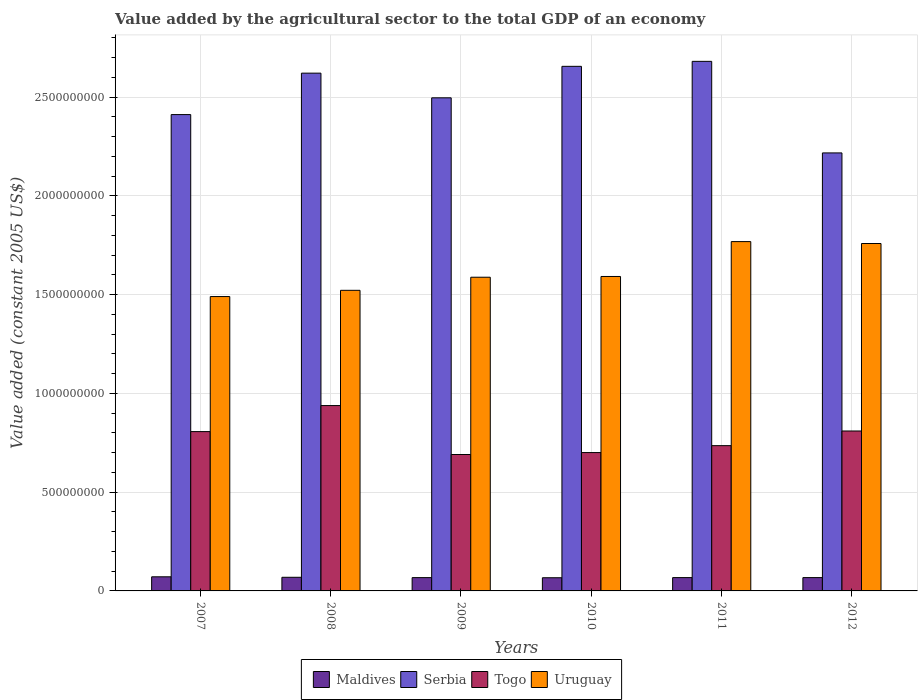How many groups of bars are there?
Keep it short and to the point. 6. Are the number of bars per tick equal to the number of legend labels?
Your response must be concise. Yes. Are the number of bars on each tick of the X-axis equal?
Keep it short and to the point. Yes. How many bars are there on the 5th tick from the right?
Offer a very short reply. 4. What is the label of the 6th group of bars from the left?
Your answer should be compact. 2012. What is the value added by the agricultural sector in Uruguay in 2010?
Your response must be concise. 1.59e+09. Across all years, what is the maximum value added by the agricultural sector in Togo?
Provide a succinct answer. 9.38e+08. Across all years, what is the minimum value added by the agricultural sector in Togo?
Your response must be concise. 6.91e+08. In which year was the value added by the agricultural sector in Togo maximum?
Ensure brevity in your answer.  2008. In which year was the value added by the agricultural sector in Uruguay minimum?
Give a very brief answer. 2007. What is the total value added by the agricultural sector in Serbia in the graph?
Ensure brevity in your answer.  1.51e+1. What is the difference between the value added by the agricultural sector in Maldives in 2011 and that in 2012?
Offer a very short reply. 2.60e+04. What is the difference between the value added by the agricultural sector in Serbia in 2007 and the value added by the agricultural sector in Togo in 2009?
Your response must be concise. 1.72e+09. What is the average value added by the agricultural sector in Maldives per year?
Your answer should be very brief. 6.82e+07. In the year 2007, what is the difference between the value added by the agricultural sector in Serbia and value added by the agricultural sector in Togo?
Ensure brevity in your answer.  1.60e+09. In how many years, is the value added by the agricultural sector in Serbia greater than 2400000000 US$?
Ensure brevity in your answer.  5. What is the ratio of the value added by the agricultural sector in Serbia in 2010 to that in 2011?
Your response must be concise. 0.99. Is the value added by the agricultural sector in Uruguay in 2007 less than that in 2012?
Your answer should be very brief. Yes. What is the difference between the highest and the second highest value added by the agricultural sector in Togo?
Provide a succinct answer. 1.29e+08. What is the difference between the highest and the lowest value added by the agricultural sector in Maldives?
Your answer should be very brief. 4.72e+06. In how many years, is the value added by the agricultural sector in Uruguay greater than the average value added by the agricultural sector in Uruguay taken over all years?
Your answer should be very brief. 2. Is it the case that in every year, the sum of the value added by the agricultural sector in Maldives and value added by the agricultural sector in Serbia is greater than the sum of value added by the agricultural sector in Uruguay and value added by the agricultural sector in Togo?
Keep it short and to the point. Yes. What does the 4th bar from the left in 2009 represents?
Ensure brevity in your answer.  Uruguay. What does the 1st bar from the right in 2012 represents?
Offer a terse response. Uruguay. Is it the case that in every year, the sum of the value added by the agricultural sector in Uruguay and value added by the agricultural sector in Serbia is greater than the value added by the agricultural sector in Togo?
Keep it short and to the point. Yes. What is the difference between two consecutive major ticks on the Y-axis?
Provide a short and direct response. 5.00e+08. Are the values on the major ticks of Y-axis written in scientific E-notation?
Provide a succinct answer. No. How are the legend labels stacked?
Provide a short and direct response. Horizontal. What is the title of the graph?
Keep it short and to the point. Value added by the agricultural sector to the total GDP of an economy. Does "Tuvalu" appear as one of the legend labels in the graph?
Ensure brevity in your answer.  No. What is the label or title of the X-axis?
Give a very brief answer. Years. What is the label or title of the Y-axis?
Your response must be concise. Value added (constant 2005 US$). What is the Value added (constant 2005 US$) of Maldives in 2007?
Keep it short and to the point. 7.14e+07. What is the Value added (constant 2005 US$) of Serbia in 2007?
Ensure brevity in your answer.  2.41e+09. What is the Value added (constant 2005 US$) in Togo in 2007?
Your response must be concise. 8.06e+08. What is the Value added (constant 2005 US$) in Uruguay in 2007?
Offer a very short reply. 1.49e+09. What is the Value added (constant 2005 US$) in Maldives in 2008?
Ensure brevity in your answer.  6.90e+07. What is the Value added (constant 2005 US$) of Serbia in 2008?
Provide a short and direct response. 2.62e+09. What is the Value added (constant 2005 US$) of Togo in 2008?
Give a very brief answer. 9.38e+08. What is the Value added (constant 2005 US$) of Uruguay in 2008?
Your response must be concise. 1.52e+09. What is the Value added (constant 2005 US$) of Maldives in 2009?
Give a very brief answer. 6.73e+07. What is the Value added (constant 2005 US$) in Serbia in 2009?
Keep it short and to the point. 2.50e+09. What is the Value added (constant 2005 US$) of Togo in 2009?
Make the answer very short. 6.91e+08. What is the Value added (constant 2005 US$) in Uruguay in 2009?
Provide a succinct answer. 1.59e+09. What is the Value added (constant 2005 US$) of Maldives in 2010?
Provide a succinct answer. 6.67e+07. What is the Value added (constant 2005 US$) in Serbia in 2010?
Make the answer very short. 2.66e+09. What is the Value added (constant 2005 US$) in Togo in 2010?
Give a very brief answer. 7.00e+08. What is the Value added (constant 2005 US$) in Uruguay in 2010?
Provide a succinct answer. 1.59e+09. What is the Value added (constant 2005 US$) of Maldives in 2011?
Offer a very short reply. 6.74e+07. What is the Value added (constant 2005 US$) in Serbia in 2011?
Offer a terse response. 2.68e+09. What is the Value added (constant 2005 US$) of Togo in 2011?
Give a very brief answer. 7.35e+08. What is the Value added (constant 2005 US$) in Uruguay in 2011?
Provide a short and direct response. 1.77e+09. What is the Value added (constant 2005 US$) in Maldives in 2012?
Offer a terse response. 6.74e+07. What is the Value added (constant 2005 US$) of Serbia in 2012?
Your answer should be very brief. 2.22e+09. What is the Value added (constant 2005 US$) of Togo in 2012?
Ensure brevity in your answer.  8.10e+08. What is the Value added (constant 2005 US$) of Uruguay in 2012?
Keep it short and to the point. 1.76e+09. Across all years, what is the maximum Value added (constant 2005 US$) of Maldives?
Offer a terse response. 7.14e+07. Across all years, what is the maximum Value added (constant 2005 US$) of Serbia?
Offer a terse response. 2.68e+09. Across all years, what is the maximum Value added (constant 2005 US$) of Togo?
Give a very brief answer. 9.38e+08. Across all years, what is the maximum Value added (constant 2005 US$) in Uruguay?
Provide a succinct answer. 1.77e+09. Across all years, what is the minimum Value added (constant 2005 US$) in Maldives?
Make the answer very short. 6.67e+07. Across all years, what is the minimum Value added (constant 2005 US$) of Serbia?
Provide a succinct answer. 2.22e+09. Across all years, what is the minimum Value added (constant 2005 US$) in Togo?
Offer a terse response. 6.91e+08. Across all years, what is the minimum Value added (constant 2005 US$) of Uruguay?
Give a very brief answer. 1.49e+09. What is the total Value added (constant 2005 US$) of Maldives in the graph?
Your response must be concise. 4.09e+08. What is the total Value added (constant 2005 US$) in Serbia in the graph?
Make the answer very short. 1.51e+1. What is the total Value added (constant 2005 US$) of Togo in the graph?
Provide a short and direct response. 4.68e+09. What is the total Value added (constant 2005 US$) of Uruguay in the graph?
Make the answer very short. 9.72e+09. What is the difference between the Value added (constant 2005 US$) in Maldives in 2007 and that in 2008?
Offer a very short reply. 2.43e+06. What is the difference between the Value added (constant 2005 US$) of Serbia in 2007 and that in 2008?
Your response must be concise. -2.10e+08. What is the difference between the Value added (constant 2005 US$) of Togo in 2007 and that in 2008?
Your answer should be very brief. -1.32e+08. What is the difference between the Value added (constant 2005 US$) of Uruguay in 2007 and that in 2008?
Your response must be concise. -3.15e+07. What is the difference between the Value added (constant 2005 US$) of Maldives in 2007 and that in 2009?
Provide a short and direct response. 4.13e+06. What is the difference between the Value added (constant 2005 US$) in Serbia in 2007 and that in 2009?
Your response must be concise. -8.49e+07. What is the difference between the Value added (constant 2005 US$) of Togo in 2007 and that in 2009?
Make the answer very short. 1.16e+08. What is the difference between the Value added (constant 2005 US$) of Uruguay in 2007 and that in 2009?
Give a very brief answer. -9.78e+07. What is the difference between the Value added (constant 2005 US$) in Maldives in 2007 and that in 2010?
Offer a very short reply. 4.72e+06. What is the difference between the Value added (constant 2005 US$) of Serbia in 2007 and that in 2010?
Make the answer very short. -2.44e+08. What is the difference between the Value added (constant 2005 US$) of Togo in 2007 and that in 2010?
Ensure brevity in your answer.  1.06e+08. What is the difference between the Value added (constant 2005 US$) in Uruguay in 2007 and that in 2010?
Your answer should be very brief. -1.02e+08. What is the difference between the Value added (constant 2005 US$) in Maldives in 2007 and that in 2011?
Provide a short and direct response. 4.01e+06. What is the difference between the Value added (constant 2005 US$) in Serbia in 2007 and that in 2011?
Ensure brevity in your answer.  -2.69e+08. What is the difference between the Value added (constant 2005 US$) of Togo in 2007 and that in 2011?
Offer a very short reply. 7.11e+07. What is the difference between the Value added (constant 2005 US$) of Uruguay in 2007 and that in 2011?
Make the answer very short. -2.78e+08. What is the difference between the Value added (constant 2005 US$) in Maldives in 2007 and that in 2012?
Your response must be concise. 4.04e+06. What is the difference between the Value added (constant 2005 US$) in Serbia in 2007 and that in 2012?
Offer a very short reply. 1.94e+08. What is the difference between the Value added (constant 2005 US$) in Togo in 2007 and that in 2012?
Provide a succinct answer. -3.08e+06. What is the difference between the Value added (constant 2005 US$) of Uruguay in 2007 and that in 2012?
Provide a succinct answer. -2.69e+08. What is the difference between the Value added (constant 2005 US$) in Maldives in 2008 and that in 2009?
Ensure brevity in your answer.  1.70e+06. What is the difference between the Value added (constant 2005 US$) of Serbia in 2008 and that in 2009?
Make the answer very short. 1.25e+08. What is the difference between the Value added (constant 2005 US$) of Togo in 2008 and that in 2009?
Your answer should be very brief. 2.48e+08. What is the difference between the Value added (constant 2005 US$) of Uruguay in 2008 and that in 2009?
Offer a terse response. -6.63e+07. What is the difference between the Value added (constant 2005 US$) of Maldives in 2008 and that in 2010?
Provide a short and direct response. 2.29e+06. What is the difference between the Value added (constant 2005 US$) of Serbia in 2008 and that in 2010?
Your response must be concise. -3.45e+07. What is the difference between the Value added (constant 2005 US$) of Togo in 2008 and that in 2010?
Your answer should be very brief. 2.38e+08. What is the difference between the Value added (constant 2005 US$) of Uruguay in 2008 and that in 2010?
Your answer should be very brief. -7.01e+07. What is the difference between the Value added (constant 2005 US$) of Maldives in 2008 and that in 2011?
Your answer should be very brief. 1.59e+06. What is the difference between the Value added (constant 2005 US$) in Serbia in 2008 and that in 2011?
Provide a succinct answer. -5.97e+07. What is the difference between the Value added (constant 2005 US$) of Togo in 2008 and that in 2011?
Keep it short and to the point. 2.03e+08. What is the difference between the Value added (constant 2005 US$) of Uruguay in 2008 and that in 2011?
Provide a short and direct response. -2.47e+08. What is the difference between the Value added (constant 2005 US$) in Maldives in 2008 and that in 2012?
Ensure brevity in your answer.  1.61e+06. What is the difference between the Value added (constant 2005 US$) of Serbia in 2008 and that in 2012?
Offer a very short reply. 4.04e+08. What is the difference between the Value added (constant 2005 US$) of Togo in 2008 and that in 2012?
Keep it short and to the point. 1.29e+08. What is the difference between the Value added (constant 2005 US$) in Uruguay in 2008 and that in 2012?
Provide a succinct answer. -2.37e+08. What is the difference between the Value added (constant 2005 US$) of Maldives in 2009 and that in 2010?
Your answer should be very brief. 5.91e+05. What is the difference between the Value added (constant 2005 US$) of Serbia in 2009 and that in 2010?
Your answer should be compact. -1.59e+08. What is the difference between the Value added (constant 2005 US$) of Togo in 2009 and that in 2010?
Offer a very short reply. -9.86e+06. What is the difference between the Value added (constant 2005 US$) of Uruguay in 2009 and that in 2010?
Provide a short and direct response. -3.84e+06. What is the difference between the Value added (constant 2005 US$) of Maldives in 2009 and that in 2011?
Keep it short and to the point. -1.14e+05. What is the difference between the Value added (constant 2005 US$) in Serbia in 2009 and that in 2011?
Ensure brevity in your answer.  -1.85e+08. What is the difference between the Value added (constant 2005 US$) of Togo in 2009 and that in 2011?
Provide a succinct answer. -4.48e+07. What is the difference between the Value added (constant 2005 US$) in Uruguay in 2009 and that in 2011?
Ensure brevity in your answer.  -1.80e+08. What is the difference between the Value added (constant 2005 US$) of Maldives in 2009 and that in 2012?
Ensure brevity in your answer.  -8.76e+04. What is the difference between the Value added (constant 2005 US$) in Serbia in 2009 and that in 2012?
Keep it short and to the point. 2.79e+08. What is the difference between the Value added (constant 2005 US$) in Togo in 2009 and that in 2012?
Provide a succinct answer. -1.19e+08. What is the difference between the Value added (constant 2005 US$) in Uruguay in 2009 and that in 2012?
Provide a succinct answer. -1.71e+08. What is the difference between the Value added (constant 2005 US$) in Maldives in 2010 and that in 2011?
Keep it short and to the point. -7.04e+05. What is the difference between the Value added (constant 2005 US$) in Serbia in 2010 and that in 2011?
Offer a terse response. -2.52e+07. What is the difference between the Value added (constant 2005 US$) in Togo in 2010 and that in 2011?
Keep it short and to the point. -3.50e+07. What is the difference between the Value added (constant 2005 US$) of Uruguay in 2010 and that in 2011?
Ensure brevity in your answer.  -1.77e+08. What is the difference between the Value added (constant 2005 US$) of Maldives in 2010 and that in 2012?
Provide a succinct answer. -6.78e+05. What is the difference between the Value added (constant 2005 US$) of Serbia in 2010 and that in 2012?
Your answer should be very brief. 4.38e+08. What is the difference between the Value added (constant 2005 US$) of Togo in 2010 and that in 2012?
Provide a short and direct response. -1.09e+08. What is the difference between the Value added (constant 2005 US$) of Uruguay in 2010 and that in 2012?
Provide a short and direct response. -1.67e+08. What is the difference between the Value added (constant 2005 US$) of Maldives in 2011 and that in 2012?
Ensure brevity in your answer.  2.60e+04. What is the difference between the Value added (constant 2005 US$) of Serbia in 2011 and that in 2012?
Your answer should be very brief. 4.64e+08. What is the difference between the Value added (constant 2005 US$) of Togo in 2011 and that in 2012?
Provide a succinct answer. -7.42e+07. What is the difference between the Value added (constant 2005 US$) in Uruguay in 2011 and that in 2012?
Give a very brief answer. 9.68e+06. What is the difference between the Value added (constant 2005 US$) in Maldives in 2007 and the Value added (constant 2005 US$) in Serbia in 2008?
Give a very brief answer. -2.55e+09. What is the difference between the Value added (constant 2005 US$) of Maldives in 2007 and the Value added (constant 2005 US$) of Togo in 2008?
Provide a succinct answer. -8.67e+08. What is the difference between the Value added (constant 2005 US$) in Maldives in 2007 and the Value added (constant 2005 US$) in Uruguay in 2008?
Provide a succinct answer. -1.45e+09. What is the difference between the Value added (constant 2005 US$) of Serbia in 2007 and the Value added (constant 2005 US$) of Togo in 2008?
Provide a short and direct response. 1.47e+09. What is the difference between the Value added (constant 2005 US$) of Serbia in 2007 and the Value added (constant 2005 US$) of Uruguay in 2008?
Give a very brief answer. 8.90e+08. What is the difference between the Value added (constant 2005 US$) in Togo in 2007 and the Value added (constant 2005 US$) in Uruguay in 2008?
Your answer should be compact. -7.15e+08. What is the difference between the Value added (constant 2005 US$) in Maldives in 2007 and the Value added (constant 2005 US$) in Serbia in 2009?
Provide a succinct answer. -2.42e+09. What is the difference between the Value added (constant 2005 US$) of Maldives in 2007 and the Value added (constant 2005 US$) of Togo in 2009?
Your response must be concise. -6.19e+08. What is the difference between the Value added (constant 2005 US$) of Maldives in 2007 and the Value added (constant 2005 US$) of Uruguay in 2009?
Offer a terse response. -1.52e+09. What is the difference between the Value added (constant 2005 US$) in Serbia in 2007 and the Value added (constant 2005 US$) in Togo in 2009?
Give a very brief answer. 1.72e+09. What is the difference between the Value added (constant 2005 US$) in Serbia in 2007 and the Value added (constant 2005 US$) in Uruguay in 2009?
Your answer should be very brief. 8.23e+08. What is the difference between the Value added (constant 2005 US$) of Togo in 2007 and the Value added (constant 2005 US$) of Uruguay in 2009?
Provide a short and direct response. -7.81e+08. What is the difference between the Value added (constant 2005 US$) of Maldives in 2007 and the Value added (constant 2005 US$) of Serbia in 2010?
Make the answer very short. -2.58e+09. What is the difference between the Value added (constant 2005 US$) of Maldives in 2007 and the Value added (constant 2005 US$) of Togo in 2010?
Offer a terse response. -6.29e+08. What is the difference between the Value added (constant 2005 US$) in Maldives in 2007 and the Value added (constant 2005 US$) in Uruguay in 2010?
Make the answer very short. -1.52e+09. What is the difference between the Value added (constant 2005 US$) in Serbia in 2007 and the Value added (constant 2005 US$) in Togo in 2010?
Your answer should be very brief. 1.71e+09. What is the difference between the Value added (constant 2005 US$) in Serbia in 2007 and the Value added (constant 2005 US$) in Uruguay in 2010?
Your answer should be compact. 8.19e+08. What is the difference between the Value added (constant 2005 US$) of Togo in 2007 and the Value added (constant 2005 US$) of Uruguay in 2010?
Offer a terse response. -7.85e+08. What is the difference between the Value added (constant 2005 US$) of Maldives in 2007 and the Value added (constant 2005 US$) of Serbia in 2011?
Give a very brief answer. -2.61e+09. What is the difference between the Value added (constant 2005 US$) of Maldives in 2007 and the Value added (constant 2005 US$) of Togo in 2011?
Give a very brief answer. -6.64e+08. What is the difference between the Value added (constant 2005 US$) of Maldives in 2007 and the Value added (constant 2005 US$) of Uruguay in 2011?
Offer a very short reply. -1.70e+09. What is the difference between the Value added (constant 2005 US$) of Serbia in 2007 and the Value added (constant 2005 US$) of Togo in 2011?
Ensure brevity in your answer.  1.68e+09. What is the difference between the Value added (constant 2005 US$) of Serbia in 2007 and the Value added (constant 2005 US$) of Uruguay in 2011?
Keep it short and to the point. 6.43e+08. What is the difference between the Value added (constant 2005 US$) in Togo in 2007 and the Value added (constant 2005 US$) in Uruguay in 2011?
Ensure brevity in your answer.  -9.62e+08. What is the difference between the Value added (constant 2005 US$) in Maldives in 2007 and the Value added (constant 2005 US$) in Serbia in 2012?
Make the answer very short. -2.15e+09. What is the difference between the Value added (constant 2005 US$) of Maldives in 2007 and the Value added (constant 2005 US$) of Togo in 2012?
Your response must be concise. -7.38e+08. What is the difference between the Value added (constant 2005 US$) in Maldives in 2007 and the Value added (constant 2005 US$) in Uruguay in 2012?
Ensure brevity in your answer.  -1.69e+09. What is the difference between the Value added (constant 2005 US$) in Serbia in 2007 and the Value added (constant 2005 US$) in Togo in 2012?
Give a very brief answer. 1.60e+09. What is the difference between the Value added (constant 2005 US$) in Serbia in 2007 and the Value added (constant 2005 US$) in Uruguay in 2012?
Offer a very short reply. 6.53e+08. What is the difference between the Value added (constant 2005 US$) of Togo in 2007 and the Value added (constant 2005 US$) of Uruguay in 2012?
Keep it short and to the point. -9.52e+08. What is the difference between the Value added (constant 2005 US$) in Maldives in 2008 and the Value added (constant 2005 US$) in Serbia in 2009?
Provide a short and direct response. -2.43e+09. What is the difference between the Value added (constant 2005 US$) of Maldives in 2008 and the Value added (constant 2005 US$) of Togo in 2009?
Provide a succinct answer. -6.22e+08. What is the difference between the Value added (constant 2005 US$) of Maldives in 2008 and the Value added (constant 2005 US$) of Uruguay in 2009?
Your response must be concise. -1.52e+09. What is the difference between the Value added (constant 2005 US$) in Serbia in 2008 and the Value added (constant 2005 US$) in Togo in 2009?
Give a very brief answer. 1.93e+09. What is the difference between the Value added (constant 2005 US$) of Serbia in 2008 and the Value added (constant 2005 US$) of Uruguay in 2009?
Ensure brevity in your answer.  1.03e+09. What is the difference between the Value added (constant 2005 US$) in Togo in 2008 and the Value added (constant 2005 US$) in Uruguay in 2009?
Offer a terse response. -6.50e+08. What is the difference between the Value added (constant 2005 US$) of Maldives in 2008 and the Value added (constant 2005 US$) of Serbia in 2010?
Your response must be concise. -2.59e+09. What is the difference between the Value added (constant 2005 US$) of Maldives in 2008 and the Value added (constant 2005 US$) of Togo in 2010?
Your response must be concise. -6.31e+08. What is the difference between the Value added (constant 2005 US$) in Maldives in 2008 and the Value added (constant 2005 US$) in Uruguay in 2010?
Your response must be concise. -1.52e+09. What is the difference between the Value added (constant 2005 US$) of Serbia in 2008 and the Value added (constant 2005 US$) of Togo in 2010?
Offer a terse response. 1.92e+09. What is the difference between the Value added (constant 2005 US$) in Serbia in 2008 and the Value added (constant 2005 US$) in Uruguay in 2010?
Keep it short and to the point. 1.03e+09. What is the difference between the Value added (constant 2005 US$) in Togo in 2008 and the Value added (constant 2005 US$) in Uruguay in 2010?
Offer a terse response. -6.54e+08. What is the difference between the Value added (constant 2005 US$) of Maldives in 2008 and the Value added (constant 2005 US$) of Serbia in 2011?
Offer a terse response. -2.61e+09. What is the difference between the Value added (constant 2005 US$) of Maldives in 2008 and the Value added (constant 2005 US$) of Togo in 2011?
Provide a short and direct response. -6.66e+08. What is the difference between the Value added (constant 2005 US$) in Maldives in 2008 and the Value added (constant 2005 US$) in Uruguay in 2011?
Provide a short and direct response. -1.70e+09. What is the difference between the Value added (constant 2005 US$) of Serbia in 2008 and the Value added (constant 2005 US$) of Togo in 2011?
Offer a terse response. 1.89e+09. What is the difference between the Value added (constant 2005 US$) of Serbia in 2008 and the Value added (constant 2005 US$) of Uruguay in 2011?
Provide a succinct answer. 8.53e+08. What is the difference between the Value added (constant 2005 US$) of Togo in 2008 and the Value added (constant 2005 US$) of Uruguay in 2011?
Your answer should be compact. -8.30e+08. What is the difference between the Value added (constant 2005 US$) in Maldives in 2008 and the Value added (constant 2005 US$) in Serbia in 2012?
Ensure brevity in your answer.  -2.15e+09. What is the difference between the Value added (constant 2005 US$) in Maldives in 2008 and the Value added (constant 2005 US$) in Togo in 2012?
Give a very brief answer. -7.41e+08. What is the difference between the Value added (constant 2005 US$) in Maldives in 2008 and the Value added (constant 2005 US$) in Uruguay in 2012?
Ensure brevity in your answer.  -1.69e+09. What is the difference between the Value added (constant 2005 US$) in Serbia in 2008 and the Value added (constant 2005 US$) in Togo in 2012?
Offer a very short reply. 1.81e+09. What is the difference between the Value added (constant 2005 US$) in Serbia in 2008 and the Value added (constant 2005 US$) in Uruguay in 2012?
Your answer should be compact. 8.62e+08. What is the difference between the Value added (constant 2005 US$) in Togo in 2008 and the Value added (constant 2005 US$) in Uruguay in 2012?
Keep it short and to the point. -8.20e+08. What is the difference between the Value added (constant 2005 US$) of Maldives in 2009 and the Value added (constant 2005 US$) of Serbia in 2010?
Provide a succinct answer. -2.59e+09. What is the difference between the Value added (constant 2005 US$) of Maldives in 2009 and the Value added (constant 2005 US$) of Togo in 2010?
Offer a terse response. -6.33e+08. What is the difference between the Value added (constant 2005 US$) of Maldives in 2009 and the Value added (constant 2005 US$) of Uruguay in 2010?
Provide a short and direct response. -1.52e+09. What is the difference between the Value added (constant 2005 US$) of Serbia in 2009 and the Value added (constant 2005 US$) of Togo in 2010?
Provide a succinct answer. 1.80e+09. What is the difference between the Value added (constant 2005 US$) in Serbia in 2009 and the Value added (constant 2005 US$) in Uruguay in 2010?
Provide a succinct answer. 9.04e+08. What is the difference between the Value added (constant 2005 US$) in Togo in 2009 and the Value added (constant 2005 US$) in Uruguay in 2010?
Your answer should be very brief. -9.01e+08. What is the difference between the Value added (constant 2005 US$) in Maldives in 2009 and the Value added (constant 2005 US$) in Serbia in 2011?
Keep it short and to the point. -2.61e+09. What is the difference between the Value added (constant 2005 US$) of Maldives in 2009 and the Value added (constant 2005 US$) of Togo in 2011?
Provide a succinct answer. -6.68e+08. What is the difference between the Value added (constant 2005 US$) in Maldives in 2009 and the Value added (constant 2005 US$) in Uruguay in 2011?
Your response must be concise. -1.70e+09. What is the difference between the Value added (constant 2005 US$) of Serbia in 2009 and the Value added (constant 2005 US$) of Togo in 2011?
Make the answer very short. 1.76e+09. What is the difference between the Value added (constant 2005 US$) in Serbia in 2009 and the Value added (constant 2005 US$) in Uruguay in 2011?
Your answer should be very brief. 7.28e+08. What is the difference between the Value added (constant 2005 US$) in Togo in 2009 and the Value added (constant 2005 US$) in Uruguay in 2011?
Provide a succinct answer. -1.08e+09. What is the difference between the Value added (constant 2005 US$) in Maldives in 2009 and the Value added (constant 2005 US$) in Serbia in 2012?
Give a very brief answer. -2.15e+09. What is the difference between the Value added (constant 2005 US$) in Maldives in 2009 and the Value added (constant 2005 US$) in Togo in 2012?
Ensure brevity in your answer.  -7.42e+08. What is the difference between the Value added (constant 2005 US$) of Maldives in 2009 and the Value added (constant 2005 US$) of Uruguay in 2012?
Provide a succinct answer. -1.69e+09. What is the difference between the Value added (constant 2005 US$) in Serbia in 2009 and the Value added (constant 2005 US$) in Togo in 2012?
Provide a short and direct response. 1.69e+09. What is the difference between the Value added (constant 2005 US$) in Serbia in 2009 and the Value added (constant 2005 US$) in Uruguay in 2012?
Give a very brief answer. 7.38e+08. What is the difference between the Value added (constant 2005 US$) in Togo in 2009 and the Value added (constant 2005 US$) in Uruguay in 2012?
Give a very brief answer. -1.07e+09. What is the difference between the Value added (constant 2005 US$) of Maldives in 2010 and the Value added (constant 2005 US$) of Serbia in 2011?
Ensure brevity in your answer.  -2.61e+09. What is the difference between the Value added (constant 2005 US$) of Maldives in 2010 and the Value added (constant 2005 US$) of Togo in 2011?
Provide a succinct answer. -6.69e+08. What is the difference between the Value added (constant 2005 US$) of Maldives in 2010 and the Value added (constant 2005 US$) of Uruguay in 2011?
Provide a short and direct response. -1.70e+09. What is the difference between the Value added (constant 2005 US$) in Serbia in 2010 and the Value added (constant 2005 US$) in Togo in 2011?
Provide a short and direct response. 1.92e+09. What is the difference between the Value added (constant 2005 US$) of Serbia in 2010 and the Value added (constant 2005 US$) of Uruguay in 2011?
Offer a terse response. 8.87e+08. What is the difference between the Value added (constant 2005 US$) in Togo in 2010 and the Value added (constant 2005 US$) in Uruguay in 2011?
Give a very brief answer. -1.07e+09. What is the difference between the Value added (constant 2005 US$) in Maldives in 2010 and the Value added (constant 2005 US$) in Serbia in 2012?
Ensure brevity in your answer.  -2.15e+09. What is the difference between the Value added (constant 2005 US$) in Maldives in 2010 and the Value added (constant 2005 US$) in Togo in 2012?
Keep it short and to the point. -7.43e+08. What is the difference between the Value added (constant 2005 US$) of Maldives in 2010 and the Value added (constant 2005 US$) of Uruguay in 2012?
Your response must be concise. -1.69e+09. What is the difference between the Value added (constant 2005 US$) in Serbia in 2010 and the Value added (constant 2005 US$) in Togo in 2012?
Make the answer very short. 1.85e+09. What is the difference between the Value added (constant 2005 US$) in Serbia in 2010 and the Value added (constant 2005 US$) in Uruguay in 2012?
Ensure brevity in your answer.  8.97e+08. What is the difference between the Value added (constant 2005 US$) in Togo in 2010 and the Value added (constant 2005 US$) in Uruguay in 2012?
Offer a very short reply. -1.06e+09. What is the difference between the Value added (constant 2005 US$) of Maldives in 2011 and the Value added (constant 2005 US$) of Serbia in 2012?
Your answer should be very brief. -2.15e+09. What is the difference between the Value added (constant 2005 US$) of Maldives in 2011 and the Value added (constant 2005 US$) of Togo in 2012?
Provide a short and direct response. -7.42e+08. What is the difference between the Value added (constant 2005 US$) in Maldives in 2011 and the Value added (constant 2005 US$) in Uruguay in 2012?
Make the answer very short. -1.69e+09. What is the difference between the Value added (constant 2005 US$) of Serbia in 2011 and the Value added (constant 2005 US$) of Togo in 2012?
Offer a terse response. 1.87e+09. What is the difference between the Value added (constant 2005 US$) of Serbia in 2011 and the Value added (constant 2005 US$) of Uruguay in 2012?
Your response must be concise. 9.22e+08. What is the difference between the Value added (constant 2005 US$) in Togo in 2011 and the Value added (constant 2005 US$) in Uruguay in 2012?
Ensure brevity in your answer.  -1.02e+09. What is the average Value added (constant 2005 US$) in Maldives per year?
Provide a short and direct response. 6.82e+07. What is the average Value added (constant 2005 US$) in Serbia per year?
Your answer should be compact. 2.51e+09. What is the average Value added (constant 2005 US$) of Togo per year?
Your answer should be compact. 7.80e+08. What is the average Value added (constant 2005 US$) of Uruguay per year?
Offer a terse response. 1.62e+09. In the year 2007, what is the difference between the Value added (constant 2005 US$) in Maldives and Value added (constant 2005 US$) in Serbia?
Provide a succinct answer. -2.34e+09. In the year 2007, what is the difference between the Value added (constant 2005 US$) in Maldives and Value added (constant 2005 US$) in Togo?
Your answer should be compact. -7.35e+08. In the year 2007, what is the difference between the Value added (constant 2005 US$) in Maldives and Value added (constant 2005 US$) in Uruguay?
Make the answer very short. -1.42e+09. In the year 2007, what is the difference between the Value added (constant 2005 US$) in Serbia and Value added (constant 2005 US$) in Togo?
Offer a terse response. 1.60e+09. In the year 2007, what is the difference between the Value added (constant 2005 US$) of Serbia and Value added (constant 2005 US$) of Uruguay?
Your answer should be compact. 9.21e+08. In the year 2007, what is the difference between the Value added (constant 2005 US$) of Togo and Value added (constant 2005 US$) of Uruguay?
Keep it short and to the point. -6.84e+08. In the year 2008, what is the difference between the Value added (constant 2005 US$) of Maldives and Value added (constant 2005 US$) of Serbia?
Ensure brevity in your answer.  -2.55e+09. In the year 2008, what is the difference between the Value added (constant 2005 US$) of Maldives and Value added (constant 2005 US$) of Togo?
Make the answer very short. -8.69e+08. In the year 2008, what is the difference between the Value added (constant 2005 US$) in Maldives and Value added (constant 2005 US$) in Uruguay?
Offer a very short reply. -1.45e+09. In the year 2008, what is the difference between the Value added (constant 2005 US$) of Serbia and Value added (constant 2005 US$) of Togo?
Ensure brevity in your answer.  1.68e+09. In the year 2008, what is the difference between the Value added (constant 2005 US$) in Serbia and Value added (constant 2005 US$) in Uruguay?
Give a very brief answer. 1.10e+09. In the year 2008, what is the difference between the Value added (constant 2005 US$) of Togo and Value added (constant 2005 US$) of Uruguay?
Offer a very short reply. -5.83e+08. In the year 2009, what is the difference between the Value added (constant 2005 US$) in Maldives and Value added (constant 2005 US$) in Serbia?
Provide a short and direct response. -2.43e+09. In the year 2009, what is the difference between the Value added (constant 2005 US$) of Maldives and Value added (constant 2005 US$) of Togo?
Offer a very short reply. -6.23e+08. In the year 2009, what is the difference between the Value added (constant 2005 US$) in Maldives and Value added (constant 2005 US$) in Uruguay?
Your answer should be compact. -1.52e+09. In the year 2009, what is the difference between the Value added (constant 2005 US$) in Serbia and Value added (constant 2005 US$) in Togo?
Your answer should be compact. 1.81e+09. In the year 2009, what is the difference between the Value added (constant 2005 US$) of Serbia and Value added (constant 2005 US$) of Uruguay?
Provide a short and direct response. 9.08e+08. In the year 2009, what is the difference between the Value added (constant 2005 US$) of Togo and Value added (constant 2005 US$) of Uruguay?
Provide a succinct answer. -8.97e+08. In the year 2010, what is the difference between the Value added (constant 2005 US$) in Maldives and Value added (constant 2005 US$) in Serbia?
Offer a terse response. -2.59e+09. In the year 2010, what is the difference between the Value added (constant 2005 US$) in Maldives and Value added (constant 2005 US$) in Togo?
Give a very brief answer. -6.34e+08. In the year 2010, what is the difference between the Value added (constant 2005 US$) in Maldives and Value added (constant 2005 US$) in Uruguay?
Provide a succinct answer. -1.53e+09. In the year 2010, what is the difference between the Value added (constant 2005 US$) in Serbia and Value added (constant 2005 US$) in Togo?
Provide a succinct answer. 1.96e+09. In the year 2010, what is the difference between the Value added (constant 2005 US$) of Serbia and Value added (constant 2005 US$) of Uruguay?
Your response must be concise. 1.06e+09. In the year 2010, what is the difference between the Value added (constant 2005 US$) of Togo and Value added (constant 2005 US$) of Uruguay?
Your answer should be very brief. -8.91e+08. In the year 2011, what is the difference between the Value added (constant 2005 US$) in Maldives and Value added (constant 2005 US$) in Serbia?
Make the answer very short. -2.61e+09. In the year 2011, what is the difference between the Value added (constant 2005 US$) of Maldives and Value added (constant 2005 US$) of Togo?
Keep it short and to the point. -6.68e+08. In the year 2011, what is the difference between the Value added (constant 2005 US$) in Maldives and Value added (constant 2005 US$) in Uruguay?
Your answer should be very brief. -1.70e+09. In the year 2011, what is the difference between the Value added (constant 2005 US$) in Serbia and Value added (constant 2005 US$) in Togo?
Your answer should be compact. 1.95e+09. In the year 2011, what is the difference between the Value added (constant 2005 US$) of Serbia and Value added (constant 2005 US$) of Uruguay?
Offer a terse response. 9.12e+08. In the year 2011, what is the difference between the Value added (constant 2005 US$) in Togo and Value added (constant 2005 US$) in Uruguay?
Provide a short and direct response. -1.03e+09. In the year 2012, what is the difference between the Value added (constant 2005 US$) of Maldives and Value added (constant 2005 US$) of Serbia?
Ensure brevity in your answer.  -2.15e+09. In the year 2012, what is the difference between the Value added (constant 2005 US$) in Maldives and Value added (constant 2005 US$) in Togo?
Provide a succinct answer. -7.42e+08. In the year 2012, what is the difference between the Value added (constant 2005 US$) in Maldives and Value added (constant 2005 US$) in Uruguay?
Offer a very short reply. -1.69e+09. In the year 2012, what is the difference between the Value added (constant 2005 US$) in Serbia and Value added (constant 2005 US$) in Togo?
Keep it short and to the point. 1.41e+09. In the year 2012, what is the difference between the Value added (constant 2005 US$) in Serbia and Value added (constant 2005 US$) in Uruguay?
Keep it short and to the point. 4.59e+08. In the year 2012, what is the difference between the Value added (constant 2005 US$) in Togo and Value added (constant 2005 US$) in Uruguay?
Ensure brevity in your answer.  -9.49e+08. What is the ratio of the Value added (constant 2005 US$) of Maldives in 2007 to that in 2008?
Offer a very short reply. 1.04. What is the ratio of the Value added (constant 2005 US$) in Togo in 2007 to that in 2008?
Provide a short and direct response. 0.86. What is the ratio of the Value added (constant 2005 US$) of Uruguay in 2007 to that in 2008?
Ensure brevity in your answer.  0.98. What is the ratio of the Value added (constant 2005 US$) in Maldives in 2007 to that in 2009?
Your response must be concise. 1.06. What is the ratio of the Value added (constant 2005 US$) of Togo in 2007 to that in 2009?
Ensure brevity in your answer.  1.17. What is the ratio of the Value added (constant 2005 US$) in Uruguay in 2007 to that in 2009?
Ensure brevity in your answer.  0.94. What is the ratio of the Value added (constant 2005 US$) in Maldives in 2007 to that in 2010?
Your answer should be compact. 1.07. What is the ratio of the Value added (constant 2005 US$) in Serbia in 2007 to that in 2010?
Make the answer very short. 0.91. What is the ratio of the Value added (constant 2005 US$) of Togo in 2007 to that in 2010?
Ensure brevity in your answer.  1.15. What is the ratio of the Value added (constant 2005 US$) in Uruguay in 2007 to that in 2010?
Keep it short and to the point. 0.94. What is the ratio of the Value added (constant 2005 US$) in Maldives in 2007 to that in 2011?
Offer a terse response. 1.06. What is the ratio of the Value added (constant 2005 US$) in Serbia in 2007 to that in 2011?
Your answer should be compact. 0.9. What is the ratio of the Value added (constant 2005 US$) in Togo in 2007 to that in 2011?
Make the answer very short. 1.1. What is the ratio of the Value added (constant 2005 US$) in Uruguay in 2007 to that in 2011?
Offer a terse response. 0.84. What is the ratio of the Value added (constant 2005 US$) in Maldives in 2007 to that in 2012?
Provide a succinct answer. 1.06. What is the ratio of the Value added (constant 2005 US$) in Serbia in 2007 to that in 2012?
Your answer should be compact. 1.09. What is the ratio of the Value added (constant 2005 US$) in Uruguay in 2007 to that in 2012?
Provide a succinct answer. 0.85. What is the ratio of the Value added (constant 2005 US$) in Maldives in 2008 to that in 2009?
Your response must be concise. 1.03. What is the ratio of the Value added (constant 2005 US$) in Togo in 2008 to that in 2009?
Offer a terse response. 1.36. What is the ratio of the Value added (constant 2005 US$) of Maldives in 2008 to that in 2010?
Offer a very short reply. 1.03. What is the ratio of the Value added (constant 2005 US$) in Togo in 2008 to that in 2010?
Provide a short and direct response. 1.34. What is the ratio of the Value added (constant 2005 US$) of Uruguay in 2008 to that in 2010?
Offer a terse response. 0.96. What is the ratio of the Value added (constant 2005 US$) in Maldives in 2008 to that in 2011?
Your response must be concise. 1.02. What is the ratio of the Value added (constant 2005 US$) of Serbia in 2008 to that in 2011?
Keep it short and to the point. 0.98. What is the ratio of the Value added (constant 2005 US$) in Togo in 2008 to that in 2011?
Your answer should be very brief. 1.28. What is the ratio of the Value added (constant 2005 US$) of Uruguay in 2008 to that in 2011?
Ensure brevity in your answer.  0.86. What is the ratio of the Value added (constant 2005 US$) of Maldives in 2008 to that in 2012?
Your response must be concise. 1.02. What is the ratio of the Value added (constant 2005 US$) in Serbia in 2008 to that in 2012?
Ensure brevity in your answer.  1.18. What is the ratio of the Value added (constant 2005 US$) in Togo in 2008 to that in 2012?
Keep it short and to the point. 1.16. What is the ratio of the Value added (constant 2005 US$) of Uruguay in 2008 to that in 2012?
Your answer should be very brief. 0.87. What is the ratio of the Value added (constant 2005 US$) of Maldives in 2009 to that in 2010?
Your answer should be very brief. 1.01. What is the ratio of the Value added (constant 2005 US$) in Togo in 2009 to that in 2010?
Offer a terse response. 0.99. What is the ratio of the Value added (constant 2005 US$) in Serbia in 2009 to that in 2011?
Provide a short and direct response. 0.93. What is the ratio of the Value added (constant 2005 US$) of Togo in 2009 to that in 2011?
Your answer should be compact. 0.94. What is the ratio of the Value added (constant 2005 US$) in Uruguay in 2009 to that in 2011?
Offer a terse response. 0.9. What is the ratio of the Value added (constant 2005 US$) of Maldives in 2009 to that in 2012?
Keep it short and to the point. 1. What is the ratio of the Value added (constant 2005 US$) of Serbia in 2009 to that in 2012?
Your response must be concise. 1.13. What is the ratio of the Value added (constant 2005 US$) in Togo in 2009 to that in 2012?
Ensure brevity in your answer.  0.85. What is the ratio of the Value added (constant 2005 US$) of Uruguay in 2009 to that in 2012?
Keep it short and to the point. 0.9. What is the ratio of the Value added (constant 2005 US$) of Serbia in 2010 to that in 2011?
Give a very brief answer. 0.99. What is the ratio of the Value added (constant 2005 US$) in Uruguay in 2010 to that in 2011?
Your answer should be compact. 0.9. What is the ratio of the Value added (constant 2005 US$) in Serbia in 2010 to that in 2012?
Keep it short and to the point. 1.2. What is the ratio of the Value added (constant 2005 US$) of Togo in 2010 to that in 2012?
Make the answer very short. 0.87. What is the ratio of the Value added (constant 2005 US$) in Uruguay in 2010 to that in 2012?
Provide a short and direct response. 0.91. What is the ratio of the Value added (constant 2005 US$) of Serbia in 2011 to that in 2012?
Your response must be concise. 1.21. What is the ratio of the Value added (constant 2005 US$) of Togo in 2011 to that in 2012?
Give a very brief answer. 0.91. What is the difference between the highest and the second highest Value added (constant 2005 US$) in Maldives?
Provide a succinct answer. 2.43e+06. What is the difference between the highest and the second highest Value added (constant 2005 US$) in Serbia?
Your answer should be compact. 2.52e+07. What is the difference between the highest and the second highest Value added (constant 2005 US$) in Togo?
Give a very brief answer. 1.29e+08. What is the difference between the highest and the second highest Value added (constant 2005 US$) in Uruguay?
Provide a short and direct response. 9.68e+06. What is the difference between the highest and the lowest Value added (constant 2005 US$) in Maldives?
Your answer should be compact. 4.72e+06. What is the difference between the highest and the lowest Value added (constant 2005 US$) of Serbia?
Provide a short and direct response. 4.64e+08. What is the difference between the highest and the lowest Value added (constant 2005 US$) of Togo?
Provide a short and direct response. 2.48e+08. What is the difference between the highest and the lowest Value added (constant 2005 US$) in Uruguay?
Make the answer very short. 2.78e+08. 